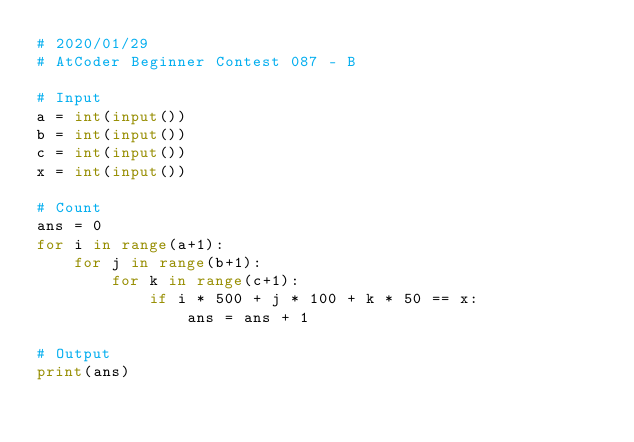<code> <loc_0><loc_0><loc_500><loc_500><_Python_># 2020/01/29
# AtCoder Beginner Contest 087 - B

# Input
a = int(input())
b = int(input())
c = int(input())
x = int(input())

# Count
ans = 0
for i in range(a+1):
    for j in range(b+1):
        for k in range(c+1):
            if i * 500 + j * 100 + k * 50 == x:
                ans = ans + 1

# Output
print(ans)</code> 